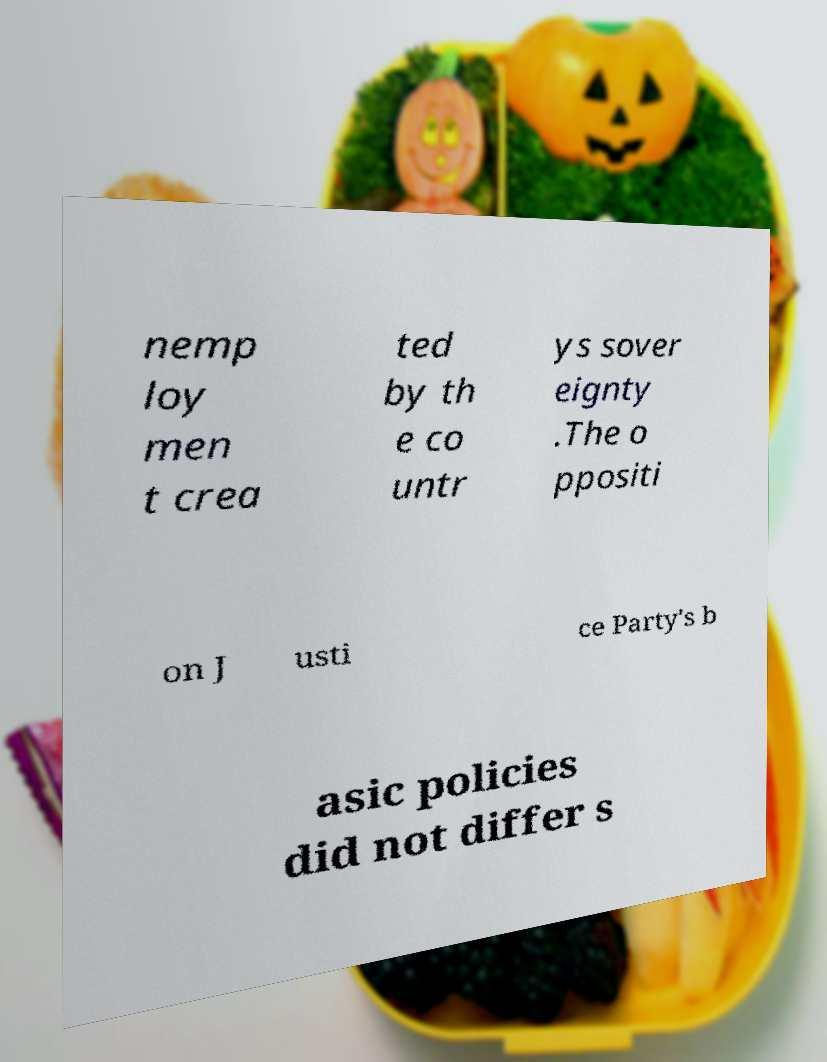Could you extract and type out the text from this image? nemp loy men t crea ted by th e co untr ys sover eignty .The o ppositi on J usti ce Party's b asic policies did not differ s 